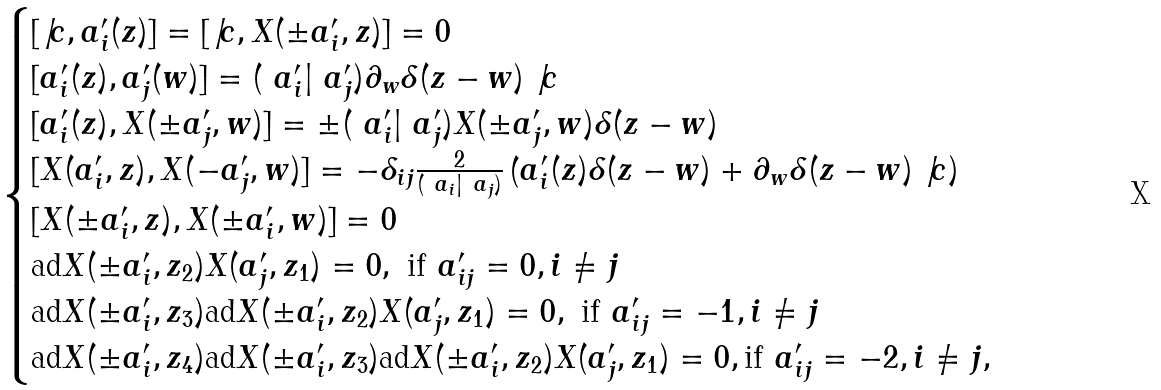Convert formula to latex. <formula><loc_0><loc_0><loc_500><loc_500>\begin{cases} [ \not { c } , a ^ { \prime } _ { i } ( z ) ] = [ \not { c } , X ( \pm a ^ { \prime } _ { i } , z ) ] = 0 \\ [ a ^ { \prime } _ { i } ( z ) , a ^ { \prime } _ { j } ( w ) ] = ( \ a ^ { \prime } _ { i } | \ a ^ { \prime } _ { j } ) \partial _ { w } \delta ( z - w ) \not { c } \\ [ a ^ { \prime } _ { i } ( z ) , X ( \pm a ^ { \prime } _ { j } , w ) ] = \pm ( \ a ^ { \prime } _ { i } | \ a ^ { \prime } _ { j } ) X ( \pm a ^ { \prime } _ { j } , w ) \delta ( z - w ) \\ [ X ( a ^ { \prime } _ { i } , z ) , X ( - a ^ { \prime } _ { j } , w ) ] = - \delta _ { i j } \frac { 2 } { ( \ a _ { i } | \ a _ { j } ) } \left ( a ^ { \prime } _ { i } ( z ) \delta ( z - w ) + \partial _ { w } \delta ( z - w ) \not { c } \right ) \\ [ X ( \pm a ^ { \prime } _ { i } , z ) , X ( \pm a ^ { \prime } _ { i } , w ) ] = 0 \\ \text {ad} X ( \pm a ^ { \prime } _ { i } , z _ { 2 } ) X ( a ^ { \prime } _ { j } , z _ { 1 } ) = 0 , \ \text {if} \ a ^ { \prime } _ { i j } = 0 , i \neq j \\ \text {ad} X ( \pm a ^ { \prime } _ { i } , z _ { 3 } ) \text {ad} X ( \pm a ^ { \prime } _ { i } , z _ { 2 } ) X ( a ^ { \prime } _ { j } , z _ { 1 } ) = 0 , \ \text {if} \ a ^ { \prime } _ { i j } = - 1 , i \neq j \\ \text {ad} X ( \pm a ^ { \prime } _ { i } , z _ { 4 } ) \text {ad} X ( \pm a ^ { \prime } _ { i } , z _ { 3 } ) \text {ad} X ( \pm a ^ { \prime } _ { i } , z _ { 2 } ) X ( a ^ { \prime } _ { j } , z _ { 1 } ) = 0 , \text {if} \ a ^ { \prime } _ { i j } = - 2 , i \neq j , \end{cases}</formula> 